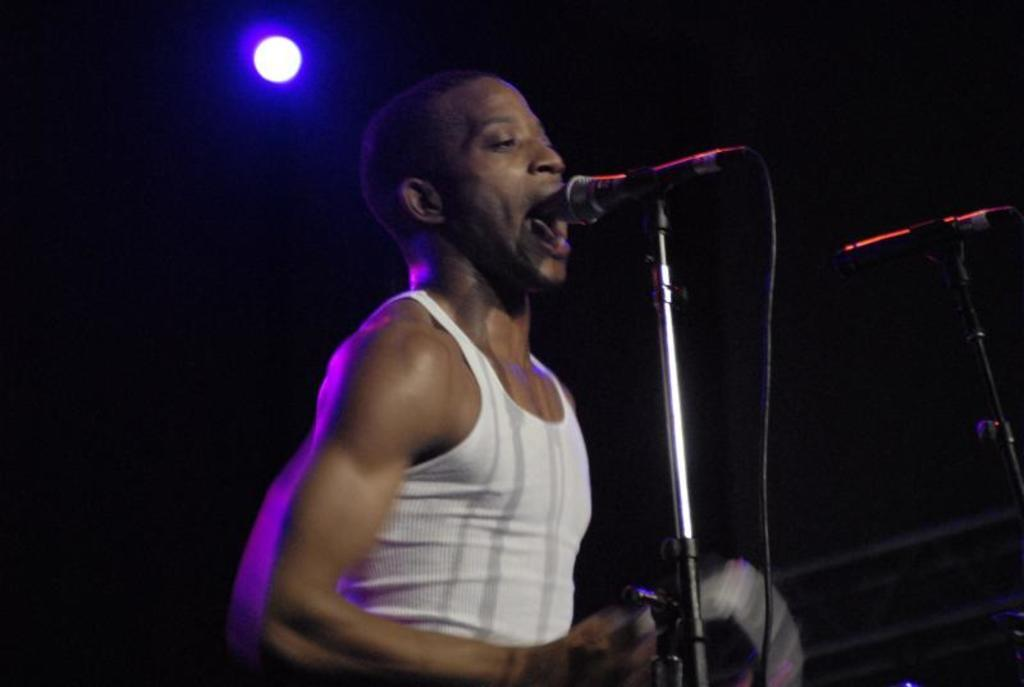Who or what is the main subject in the image? There is a person in the image. Where is the person located in the image? The person is standing on a stage. What is the person doing on the stage? The person is in front of a microphone. What type of glove is the person wearing while standing on the stage? There is no glove visible in the image, and the person is not wearing any gloves. 